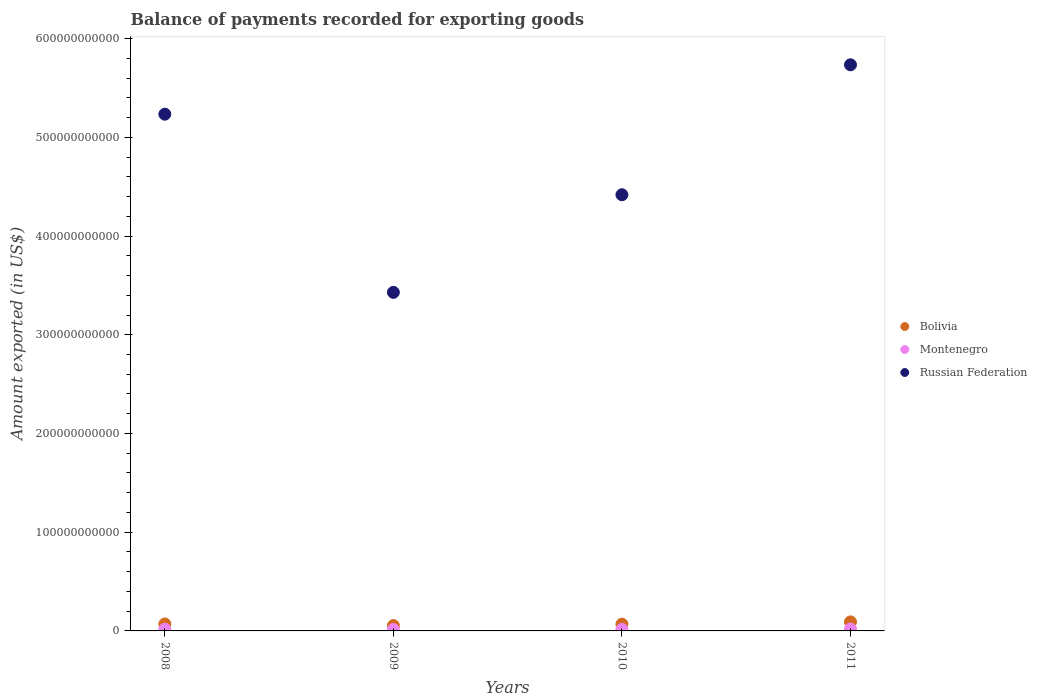What is the amount exported in Russian Federation in 2009?
Offer a very short reply. 3.43e+11. Across all years, what is the maximum amount exported in Montenegro?
Your answer should be compact. 1.93e+09. Across all years, what is the minimum amount exported in Russian Federation?
Offer a terse response. 3.43e+11. In which year was the amount exported in Bolivia maximum?
Ensure brevity in your answer.  2011. What is the total amount exported in Russian Federation in the graph?
Make the answer very short. 1.88e+12. What is the difference between the amount exported in Bolivia in 2009 and that in 2010?
Keep it short and to the point. -1.41e+09. What is the difference between the amount exported in Bolivia in 2010 and the amount exported in Russian Federation in 2009?
Your answer should be compact. -3.36e+11. What is the average amount exported in Russian Federation per year?
Keep it short and to the point. 4.70e+11. In the year 2008, what is the difference between the amount exported in Bolivia and amount exported in Russian Federation?
Keep it short and to the point. -5.16e+11. In how many years, is the amount exported in Montenegro greater than 280000000000 US$?
Offer a terse response. 0. What is the ratio of the amount exported in Montenegro in 2009 to that in 2010?
Your answer should be compact. 0.96. Is the amount exported in Montenegro in 2008 less than that in 2009?
Give a very brief answer. No. Is the difference between the amount exported in Bolivia in 2010 and 2011 greater than the difference between the amount exported in Russian Federation in 2010 and 2011?
Offer a very short reply. Yes. What is the difference between the highest and the second highest amount exported in Montenegro?
Provide a short and direct response. 1.14e+08. What is the difference between the highest and the lowest amount exported in Russian Federation?
Provide a succinct answer. 2.30e+11. Is the sum of the amount exported in Montenegro in 2009 and 2010 greater than the maximum amount exported in Russian Federation across all years?
Keep it short and to the point. No. Does the amount exported in Bolivia monotonically increase over the years?
Your response must be concise. No. Is the amount exported in Montenegro strictly less than the amount exported in Bolivia over the years?
Give a very brief answer. Yes. How many dotlines are there?
Your response must be concise. 3. How many years are there in the graph?
Offer a terse response. 4. What is the difference between two consecutive major ticks on the Y-axis?
Make the answer very short. 1.00e+11. Are the values on the major ticks of Y-axis written in scientific E-notation?
Ensure brevity in your answer.  No. Does the graph contain any zero values?
Your response must be concise. No. How are the legend labels stacked?
Provide a short and direct response. Vertical. What is the title of the graph?
Make the answer very short. Balance of payments recorded for exporting goods. What is the label or title of the X-axis?
Offer a terse response. Years. What is the label or title of the Y-axis?
Keep it short and to the point. Amount exported (in US$). What is the Amount exported (in US$) of Bolivia in 2008?
Make the answer very short. 7.02e+09. What is the Amount exported (in US$) of Montenegro in 2008?
Offer a very short reply. 1.82e+09. What is the Amount exported (in US$) of Russian Federation in 2008?
Offer a terse response. 5.23e+11. What is the Amount exported (in US$) of Bolivia in 2009?
Provide a short and direct response. 5.43e+09. What is the Amount exported (in US$) of Montenegro in 2009?
Offer a terse response. 1.44e+09. What is the Amount exported (in US$) of Russian Federation in 2009?
Your answer should be very brief. 3.43e+11. What is the Amount exported (in US$) in Bolivia in 2010?
Offer a very short reply. 6.84e+09. What is the Amount exported (in US$) in Montenegro in 2010?
Offer a very short reply. 1.50e+09. What is the Amount exported (in US$) of Russian Federation in 2010?
Provide a short and direct response. 4.42e+11. What is the Amount exported (in US$) of Bolivia in 2011?
Provide a succinct answer. 9.12e+09. What is the Amount exported (in US$) of Montenegro in 2011?
Give a very brief answer. 1.93e+09. What is the Amount exported (in US$) of Russian Federation in 2011?
Your answer should be very brief. 5.73e+11. Across all years, what is the maximum Amount exported (in US$) in Bolivia?
Make the answer very short. 9.12e+09. Across all years, what is the maximum Amount exported (in US$) in Montenegro?
Offer a very short reply. 1.93e+09. Across all years, what is the maximum Amount exported (in US$) of Russian Federation?
Ensure brevity in your answer.  5.73e+11. Across all years, what is the minimum Amount exported (in US$) in Bolivia?
Give a very brief answer. 5.43e+09. Across all years, what is the minimum Amount exported (in US$) in Montenegro?
Your answer should be compact. 1.44e+09. Across all years, what is the minimum Amount exported (in US$) in Russian Federation?
Your answer should be compact. 3.43e+11. What is the total Amount exported (in US$) of Bolivia in the graph?
Offer a very short reply. 2.84e+1. What is the total Amount exported (in US$) of Montenegro in the graph?
Provide a short and direct response. 6.68e+09. What is the total Amount exported (in US$) in Russian Federation in the graph?
Your response must be concise. 1.88e+12. What is the difference between the Amount exported (in US$) in Bolivia in 2008 and that in 2009?
Your response must be concise. 1.59e+09. What is the difference between the Amount exported (in US$) of Montenegro in 2008 and that in 2009?
Make the answer very short. 3.79e+08. What is the difference between the Amount exported (in US$) in Russian Federation in 2008 and that in 2009?
Your response must be concise. 1.80e+11. What is the difference between the Amount exported (in US$) of Bolivia in 2008 and that in 2010?
Provide a short and direct response. 1.86e+08. What is the difference between the Amount exported (in US$) in Montenegro in 2008 and that in 2010?
Your response must be concise. 3.13e+08. What is the difference between the Amount exported (in US$) of Russian Federation in 2008 and that in 2010?
Offer a very short reply. 8.16e+1. What is the difference between the Amount exported (in US$) of Bolivia in 2008 and that in 2011?
Offer a very short reply. -2.10e+09. What is the difference between the Amount exported (in US$) of Montenegro in 2008 and that in 2011?
Your answer should be very brief. -1.14e+08. What is the difference between the Amount exported (in US$) in Russian Federation in 2008 and that in 2011?
Your answer should be very brief. -5.00e+1. What is the difference between the Amount exported (in US$) of Bolivia in 2009 and that in 2010?
Your answer should be compact. -1.41e+09. What is the difference between the Amount exported (in US$) in Montenegro in 2009 and that in 2010?
Make the answer very short. -6.61e+07. What is the difference between the Amount exported (in US$) in Russian Federation in 2009 and that in 2010?
Provide a succinct answer. -9.89e+1. What is the difference between the Amount exported (in US$) in Bolivia in 2009 and that in 2011?
Your answer should be compact. -3.69e+09. What is the difference between the Amount exported (in US$) in Montenegro in 2009 and that in 2011?
Provide a short and direct response. -4.93e+08. What is the difference between the Amount exported (in US$) in Russian Federation in 2009 and that in 2011?
Make the answer very short. -2.30e+11. What is the difference between the Amount exported (in US$) in Bolivia in 2010 and that in 2011?
Your response must be concise. -2.29e+09. What is the difference between the Amount exported (in US$) in Montenegro in 2010 and that in 2011?
Provide a succinct answer. -4.27e+08. What is the difference between the Amount exported (in US$) of Russian Federation in 2010 and that in 2011?
Offer a very short reply. -1.32e+11. What is the difference between the Amount exported (in US$) of Bolivia in 2008 and the Amount exported (in US$) of Montenegro in 2009?
Your response must be concise. 5.59e+09. What is the difference between the Amount exported (in US$) of Bolivia in 2008 and the Amount exported (in US$) of Russian Federation in 2009?
Your answer should be compact. -3.36e+11. What is the difference between the Amount exported (in US$) in Montenegro in 2008 and the Amount exported (in US$) in Russian Federation in 2009?
Give a very brief answer. -3.41e+11. What is the difference between the Amount exported (in US$) in Bolivia in 2008 and the Amount exported (in US$) in Montenegro in 2010?
Keep it short and to the point. 5.52e+09. What is the difference between the Amount exported (in US$) in Bolivia in 2008 and the Amount exported (in US$) in Russian Federation in 2010?
Provide a succinct answer. -4.35e+11. What is the difference between the Amount exported (in US$) in Montenegro in 2008 and the Amount exported (in US$) in Russian Federation in 2010?
Your answer should be very brief. -4.40e+11. What is the difference between the Amount exported (in US$) in Bolivia in 2008 and the Amount exported (in US$) in Montenegro in 2011?
Give a very brief answer. 5.09e+09. What is the difference between the Amount exported (in US$) in Bolivia in 2008 and the Amount exported (in US$) in Russian Federation in 2011?
Your answer should be very brief. -5.66e+11. What is the difference between the Amount exported (in US$) in Montenegro in 2008 and the Amount exported (in US$) in Russian Federation in 2011?
Your response must be concise. -5.72e+11. What is the difference between the Amount exported (in US$) of Bolivia in 2009 and the Amount exported (in US$) of Montenegro in 2010?
Provide a short and direct response. 3.93e+09. What is the difference between the Amount exported (in US$) in Bolivia in 2009 and the Amount exported (in US$) in Russian Federation in 2010?
Provide a short and direct response. -4.36e+11. What is the difference between the Amount exported (in US$) in Montenegro in 2009 and the Amount exported (in US$) in Russian Federation in 2010?
Provide a short and direct response. -4.40e+11. What is the difference between the Amount exported (in US$) in Bolivia in 2009 and the Amount exported (in US$) in Montenegro in 2011?
Offer a very short reply. 3.50e+09. What is the difference between the Amount exported (in US$) of Bolivia in 2009 and the Amount exported (in US$) of Russian Federation in 2011?
Provide a short and direct response. -5.68e+11. What is the difference between the Amount exported (in US$) in Montenegro in 2009 and the Amount exported (in US$) in Russian Federation in 2011?
Give a very brief answer. -5.72e+11. What is the difference between the Amount exported (in US$) of Bolivia in 2010 and the Amount exported (in US$) of Montenegro in 2011?
Make the answer very short. 4.91e+09. What is the difference between the Amount exported (in US$) in Bolivia in 2010 and the Amount exported (in US$) in Russian Federation in 2011?
Make the answer very short. -5.67e+11. What is the difference between the Amount exported (in US$) of Montenegro in 2010 and the Amount exported (in US$) of Russian Federation in 2011?
Your answer should be compact. -5.72e+11. What is the average Amount exported (in US$) in Bolivia per year?
Ensure brevity in your answer.  7.10e+09. What is the average Amount exported (in US$) of Montenegro per year?
Give a very brief answer. 1.67e+09. What is the average Amount exported (in US$) of Russian Federation per year?
Your answer should be very brief. 4.70e+11. In the year 2008, what is the difference between the Amount exported (in US$) in Bolivia and Amount exported (in US$) in Montenegro?
Your answer should be compact. 5.21e+09. In the year 2008, what is the difference between the Amount exported (in US$) in Bolivia and Amount exported (in US$) in Russian Federation?
Make the answer very short. -5.16e+11. In the year 2008, what is the difference between the Amount exported (in US$) of Montenegro and Amount exported (in US$) of Russian Federation?
Offer a terse response. -5.22e+11. In the year 2009, what is the difference between the Amount exported (in US$) of Bolivia and Amount exported (in US$) of Montenegro?
Give a very brief answer. 3.99e+09. In the year 2009, what is the difference between the Amount exported (in US$) in Bolivia and Amount exported (in US$) in Russian Federation?
Provide a succinct answer. -3.38e+11. In the year 2009, what is the difference between the Amount exported (in US$) in Montenegro and Amount exported (in US$) in Russian Federation?
Make the answer very short. -3.42e+11. In the year 2010, what is the difference between the Amount exported (in US$) in Bolivia and Amount exported (in US$) in Montenegro?
Your answer should be very brief. 5.33e+09. In the year 2010, what is the difference between the Amount exported (in US$) in Bolivia and Amount exported (in US$) in Russian Federation?
Ensure brevity in your answer.  -4.35e+11. In the year 2010, what is the difference between the Amount exported (in US$) of Montenegro and Amount exported (in US$) of Russian Federation?
Make the answer very short. -4.40e+11. In the year 2011, what is the difference between the Amount exported (in US$) in Bolivia and Amount exported (in US$) in Montenegro?
Your response must be concise. 7.19e+09. In the year 2011, what is the difference between the Amount exported (in US$) in Bolivia and Amount exported (in US$) in Russian Federation?
Ensure brevity in your answer.  -5.64e+11. In the year 2011, what is the difference between the Amount exported (in US$) in Montenegro and Amount exported (in US$) in Russian Federation?
Your answer should be very brief. -5.72e+11. What is the ratio of the Amount exported (in US$) of Bolivia in 2008 to that in 2009?
Give a very brief answer. 1.29. What is the ratio of the Amount exported (in US$) of Montenegro in 2008 to that in 2009?
Provide a short and direct response. 1.26. What is the ratio of the Amount exported (in US$) of Russian Federation in 2008 to that in 2009?
Give a very brief answer. 1.53. What is the ratio of the Amount exported (in US$) in Bolivia in 2008 to that in 2010?
Offer a very short reply. 1.03. What is the ratio of the Amount exported (in US$) in Montenegro in 2008 to that in 2010?
Your answer should be very brief. 1.21. What is the ratio of the Amount exported (in US$) of Russian Federation in 2008 to that in 2010?
Offer a very short reply. 1.18. What is the ratio of the Amount exported (in US$) in Bolivia in 2008 to that in 2011?
Offer a very short reply. 0.77. What is the ratio of the Amount exported (in US$) of Montenegro in 2008 to that in 2011?
Offer a very short reply. 0.94. What is the ratio of the Amount exported (in US$) of Russian Federation in 2008 to that in 2011?
Keep it short and to the point. 0.91. What is the ratio of the Amount exported (in US$) of Bolivia in 2009 to that in 2010?
Offer a very short reply. 0.79. What is the ratio of the Amount exported (in US$) of Montenegro in 2009 to that in 2010?
Your answer should be compact. 0.96. What is the ratio of the Amount exported (in US$) in Russian Federation in 2009 to that in 2010?
Provide a succinct answer. 0.78. What is the ratio of the Amount exported (in US$) in Bolivia in 2009 to that in 2011?
Give a very brief answer. 0.6. What is the ratio of the Amount exported (in US$) in Montenegro in 2009 to that in 2011?
Your response must be concise. 0.74. What is the ratio of the Amount exported (in US$) in Russian Federation in 2009 to that in 2011?
Your answer should be compact. 0.6. What is the ratio of the Amount exported (in US$) in Bolivia in 2010 to that in 2011?
Provide a short and direct response. 0.75. What is the ratio of the Amount exported (in US$) in Montenegro in 2010 to that in 2011?
Keep it short and to the point. 0.78. What is the ratio of the Amount exported (in US$) in Russian Federation in 2010 to that in 2011?
Provide a short and direct response. 0.77. What is the difference between the highest and the second highest Amount exported (in US$) of Bolivia?
Give a very brief answer. 2.10e+09. What is the difference between the highest and the second highest Amount exported (in US$) in Montenegro?
Give a very brief answer. 1.14e+08. What is the difference between the highest and the second highest Amount exported (in US$) of Russian Federation?
Make the answer very short. 5.00e+1. What is the difference between the highest and the lowest Amount exported (in US$) in Bolivia?
Ensure brevity in your answer.  3.69e+09. What is the difference between the highest and the lowest Amount exported (in US$) in Montenegro?
Offer a terse response. 4.93e+08. What is the difference between the highest and the lowest Amount exported (in US$) of Russian Federation?
Make the answer very short. 2.30e+11. 